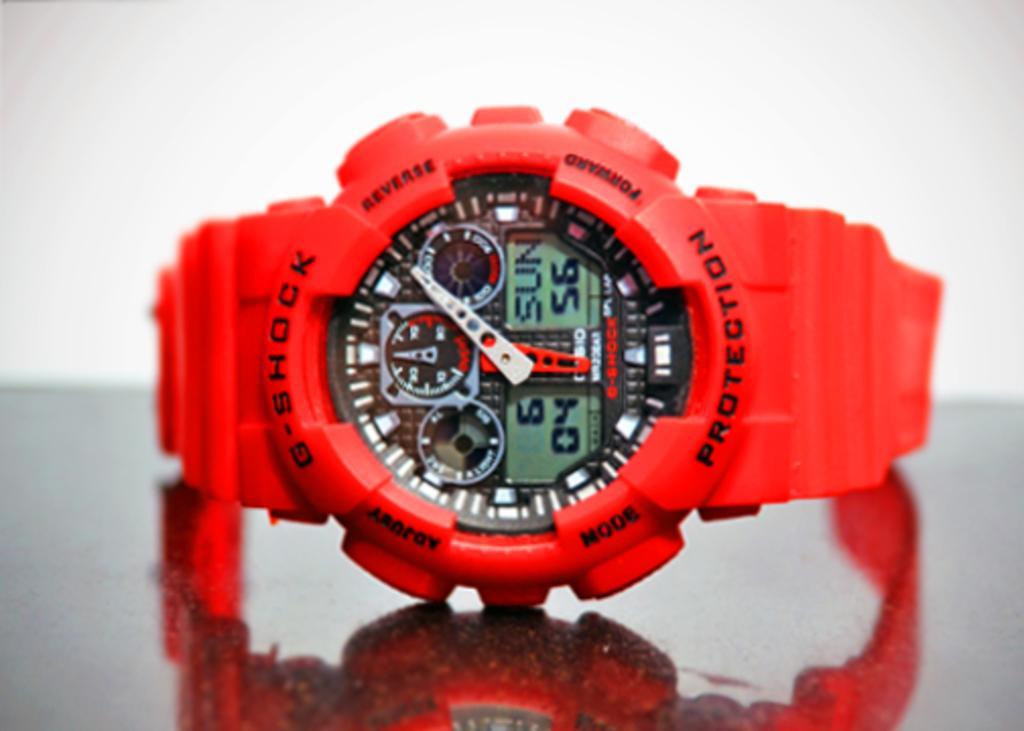In one or two sentences, can you explain what this image depicts? In this image we can see a red colored watch, with some text on it and there is a reflect of the watch on the surface of the table. 